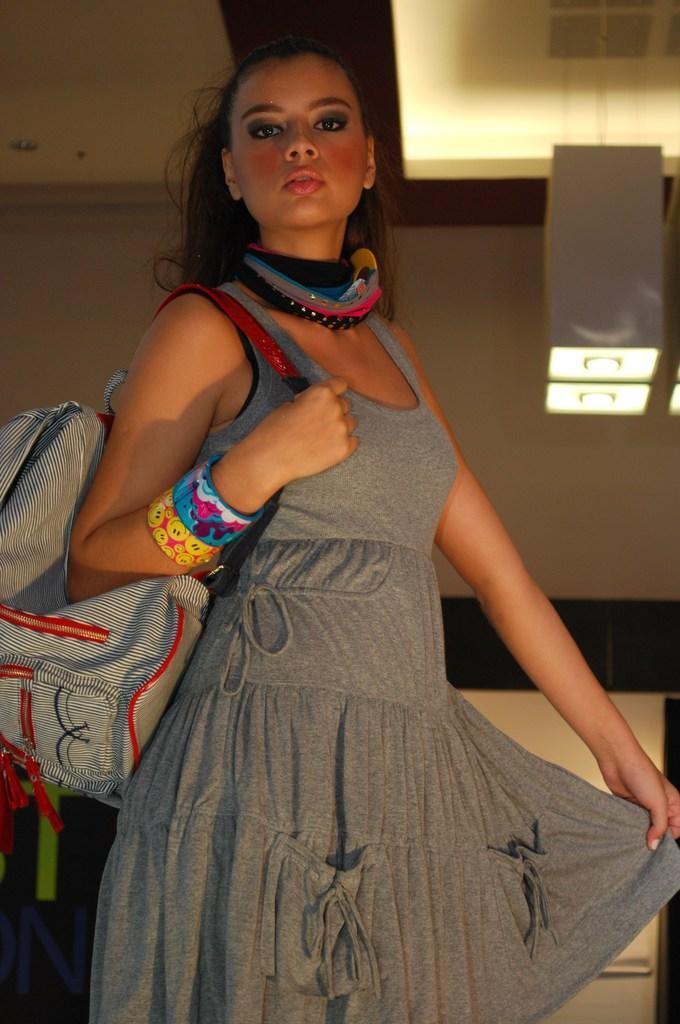Could you give a brief overview of what you see in this image? A person is standing wearing a grey dress, bangles and a bag. Behind her there are lights. 